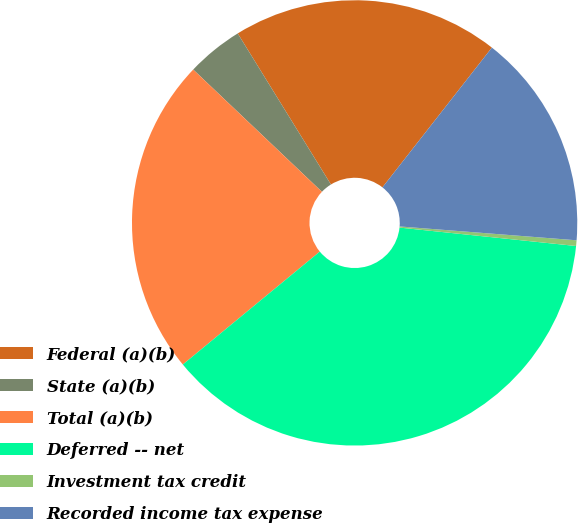<chart> <loc_0><loc_0><loc_500><loc_500><pie_chart><fcel>Federal (a)(b)<fcel>State (a)(b)<fcel>Total (a)(b)<fcel>Deferred -- net<fcel>Investment tax credit<fcel>Recorded income tax expense<nl><fcel>19.37%<fcel>4.11%<fcel>23.06%<fcel>37.37%<fcel>0.41%<fcel>15.67%<nl></chart> 